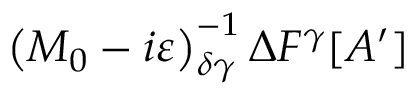<formula> <loc_0><loc_0><loc_500><loc_500>\left ( M _ { 0 } - i \varepsilon \right ) _ { \delta \gamma } ^ { - 1 } \Delta F ^ { \gamma } [ A ^ { \prime } ]</formula> 